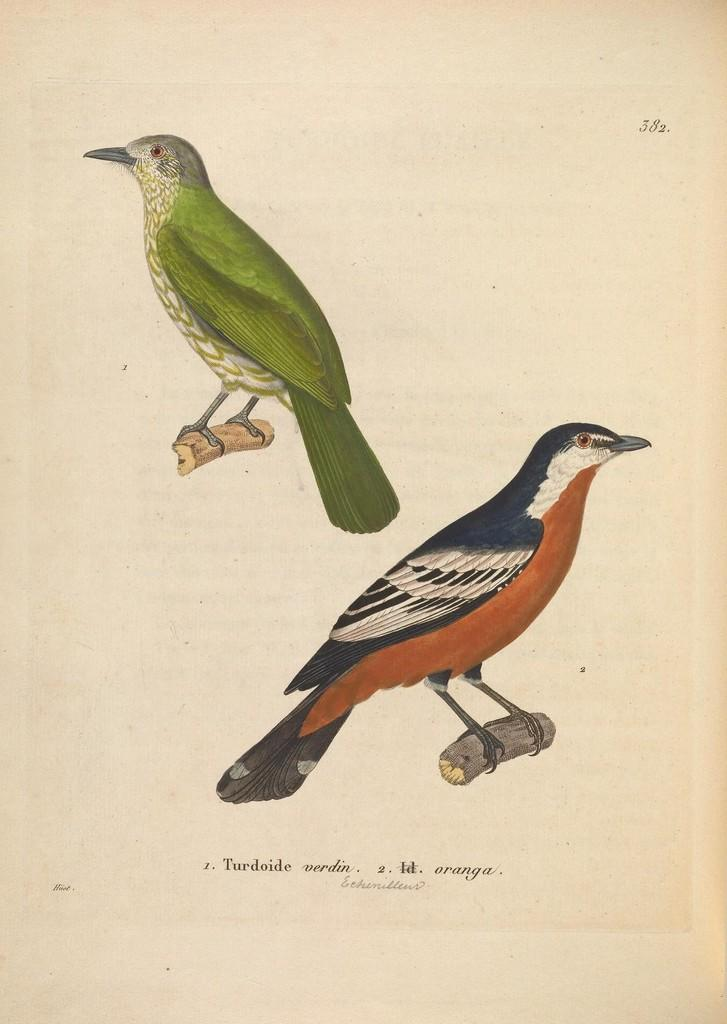How many birds can be seen in the image? There are two birds in the image. What are the birds perched on? The birds are on a wooden object. What else is present in the image besides the birds? There is text and numbers in the image. What is the color of the background in the image? The background of the image is white in color. Can you tell me what the brother of the bird is doing in the image? There is no brother of the bird present in the image, as birds do not have siblings in the same way humans do. 